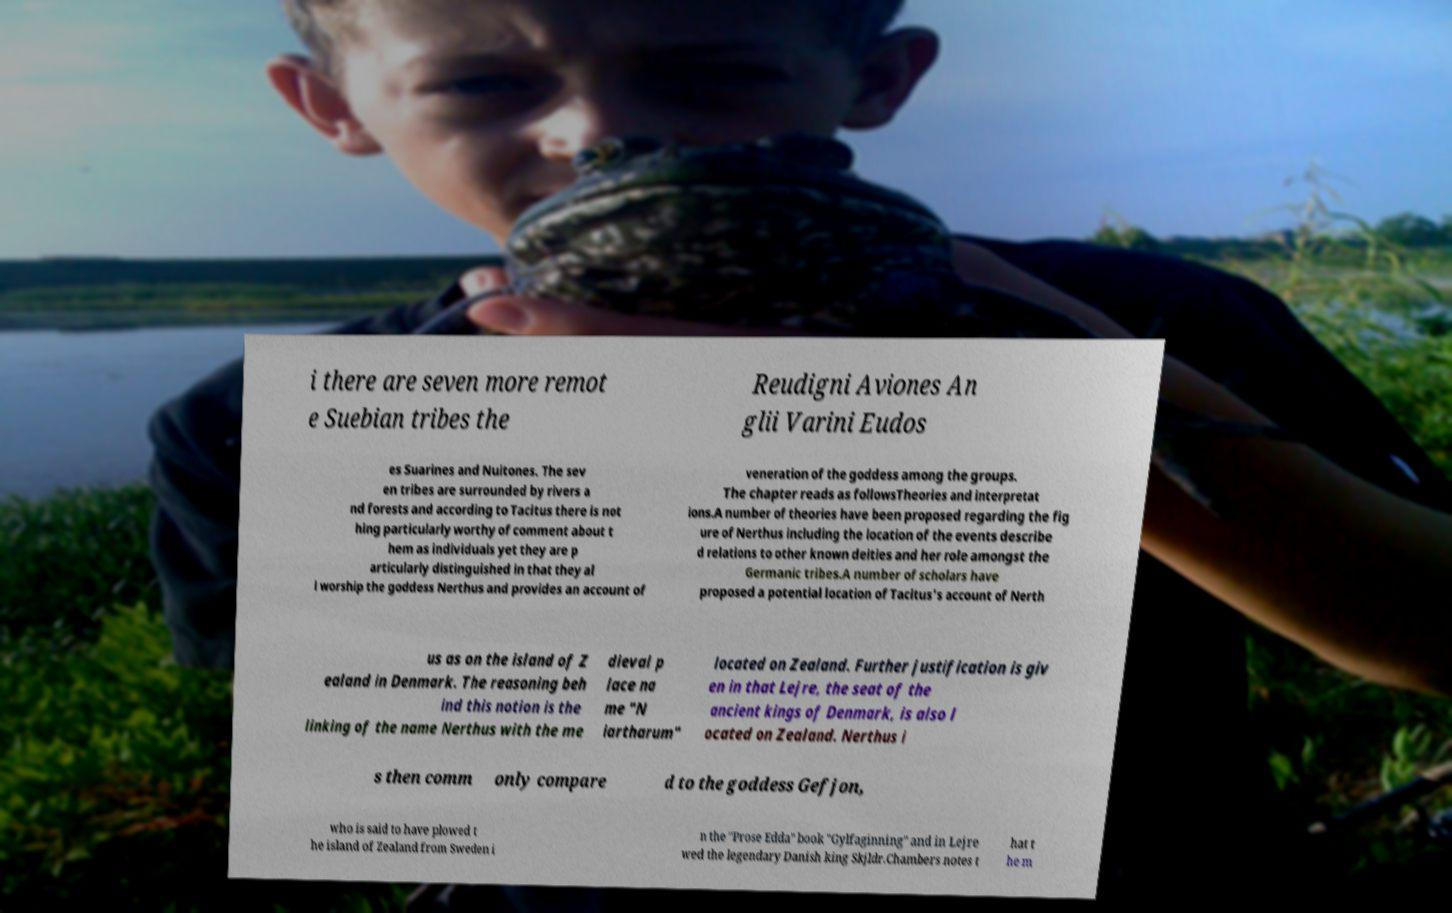Can you accurately transcribe the text from the provided image for me? i there are seven more remot e Suebian tribes the Reudigni Aviones An glii Varini Eudos es Suarines and Nuitones. The sev en tribes are surrounded by rivers a nd forests and according to Tacitus there is not hing particularly worthy of comment about t hem as individuals yet they are p articularly distinguished in that they al l worship the goddess Nerthus and provides an account of veneration of the goddess among the groups. The chapter reads as followsTheories and interpretat ions.A number of theories have been proposed regarding the fig ure of Nerthus including the location of the events describe d relations to other known deities and her role amongst the Germanic tribes.A number of scholars have proposed a potential location of Tacitus's account of Nerth us as on the island of Z ealand in Denmark. The reasoning beh ind this notion is the linking of the name Nerthus with the me dieval p lace na me "N iartharum" located on Zealand. Further justification is giv en in that Lejre, the seat of the ancient kings of Denmark, is also l ocated on Zealand. Nerthus i s then comm only compare d to the goddess Gefjon, who is said to have plowed t he island of Zealand from Sweden i n the "Prose Edda" book "Gylfaginning" and in Lejre wed the legendary Danish king Skjldr.Chambers notes t hat t he m 